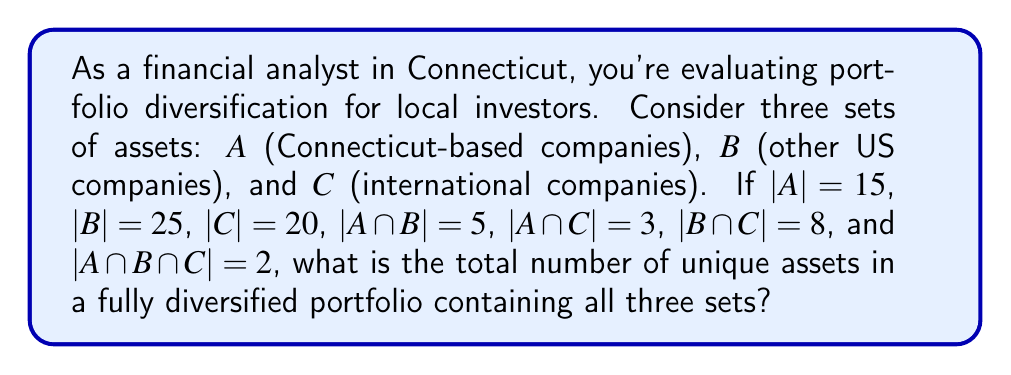Teach me how to tackle this problem. To solve this problem, we'll use the principle of inclusion-exclusion from set theory. The formula for the union of three sets is:

$$|A \cup B \cup C| = |A| + |B| + |C| - |A \cap B| - |A \cap C| - |B \cap C| + |A \cap B \cap C|$$

Let's substitute the given values:

1. $|A| = 15$
2. $|B| = 25$
3. $|C| = 20$
4. $|A \cap B| = 5$
5. $|A \cap C| = 3$
6. $|B \cap C| = 8$
7. $|A \cap B \cap C| = 2$

Now, let's calculate:

$$\begin{align*}
|A \cup B \cup C| &= 15 + 25 + 20 - 5 - 3 - 8 + 2 \\
&= 60 - 16 + 2 \\
&= 46
\end{align*}$$

This result represents the total number of unique assets in a fully diversified portfolio containing all three sets.
Answer: 46 unique assets 